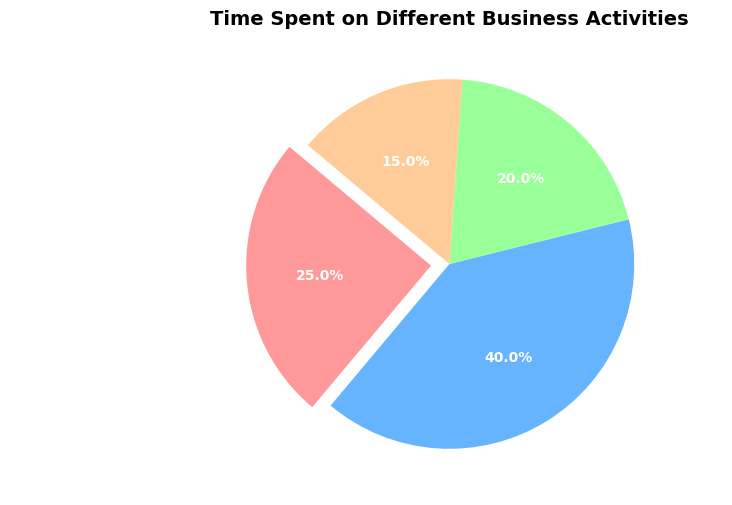Which activity takes up the most time? The largest slice of the pie chart represents the activity that takes up the most time. In this chart, Customer Service has the largest slice.
Answer: Customer Service What percentage of time is spent on Inventory Management and Marketing combined? To find the combined percentage, add the percentages of Inventory Management and Marketing. According to the chart, Inventory Management is 25% and Marketing is 20%. Therefore, 25% + 20% = 45%.
Answer: 45% How much more time is spent on Customer Service compared to Administrative Tasks? Find the difference between the time percentages spent on Customer Service and Administrative Tasks. Customer Service is 40%, while Administrative Tasks is 15%, so the difference is 40% - 15% = 25%.
Answer: 25% What activity is represented by the smallest slice of the pie chart? The smallest slice of the pie chart corresponds to the activity with the least time spent. In this chart, Administrative Tasks has the smallest slice.
Answer: Administrative Tasks What color is associated with Inventory Management in the pie chart? The pie chart uses colors to represent different activities. Inventory Management is represented by the first section, which is colored red.
Answer: Red Is the time spent on Marketing greater than the time spent on Administrative Tasks? Compare the sizes of the slices for Marketing and Administrative Tasks. Marketing is 20%, and Administrative Tasks is 15%, so Marketing is indeed greater.
Answer: Yes 